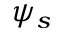Convert formula to latex. <formula><loc_0><loc_0><loc_500><loc_500>\psi _ { s }</formula> 